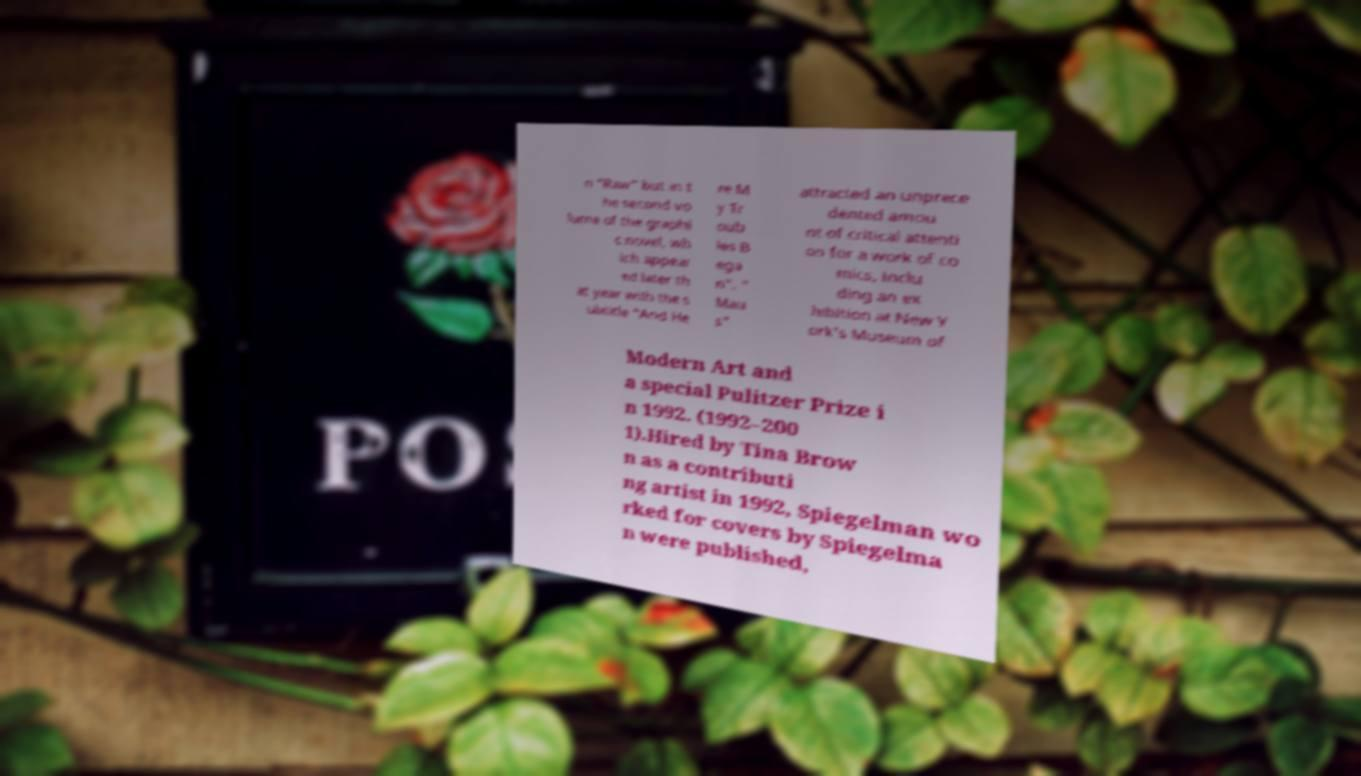What messages or text are displayed in this image? I need them in a readable, typed format. n "Raw" but in t he second vo lume of the graphi c novel, wh ich appear ed later th at year with the s ubtitle "And He re M y Tr oub les B ega n". " Mau s" attracted an unprece dented amou nt of critical attenti on for a work of co mics, inclu ding an ex hibition at New Y ork's Museum of Modern Art and a special Pulitzer Prize i n 1992. (1992–200 1).Hired by Tina Brow n as a contributi ng artist in 1992, Spiegelman wo rked for covers by Spiegelma n were published, 